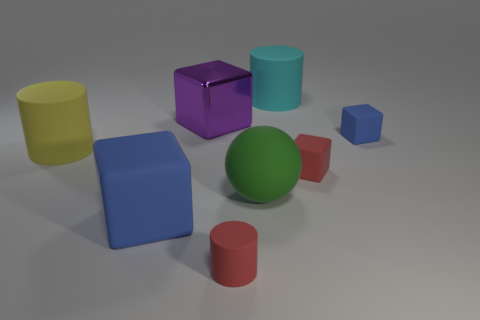Add 1 big blue objects. How many objects exist? 9 Subtract all balls. How many objects are left? 7 Subtract 0 gray spheres. How many objects are left? 8 Subtract all metallic cubes. Subtract all large red matte cylinders. How many objects are left? 7 Add 5 small red cubes. How many small red cubes are left? 6 Add 3 yellow rubber cylinders. How many yellow rubber cylinders exist? 4 